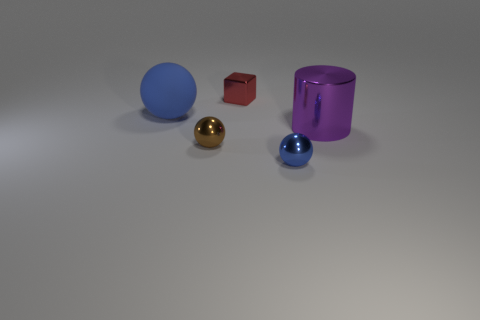What materials are the objects in the image made of? The objects in the image seem to be made of different materials. The blue sphere might be plastic, the red cube looks like it's made of metal, the brown object could be wooden, the purple cylinder appears to be glass, and the small gold sphere seems metallic, possibly gold or brass. 